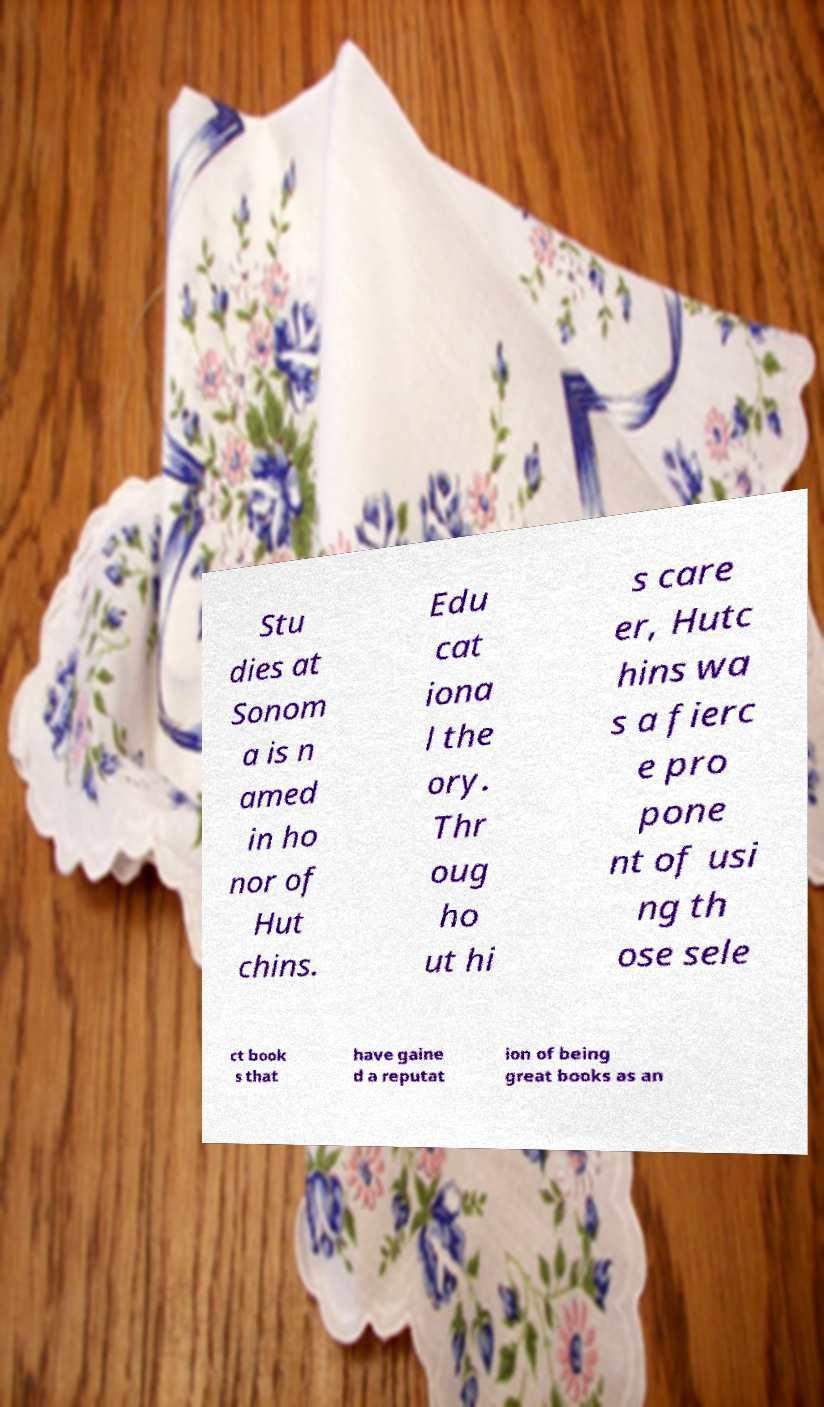Could you extract and type out the text from this image? Stu dies at Sonom a is n amed in ho nor of Hut chins. Edu cat iona l the ory. Thr oug ho ut hi s care er, Hutc hins wa s a fierc e pro pone nt of usi ng th ose sele ct book s that have gaine d a reputat ion of being great books as an 